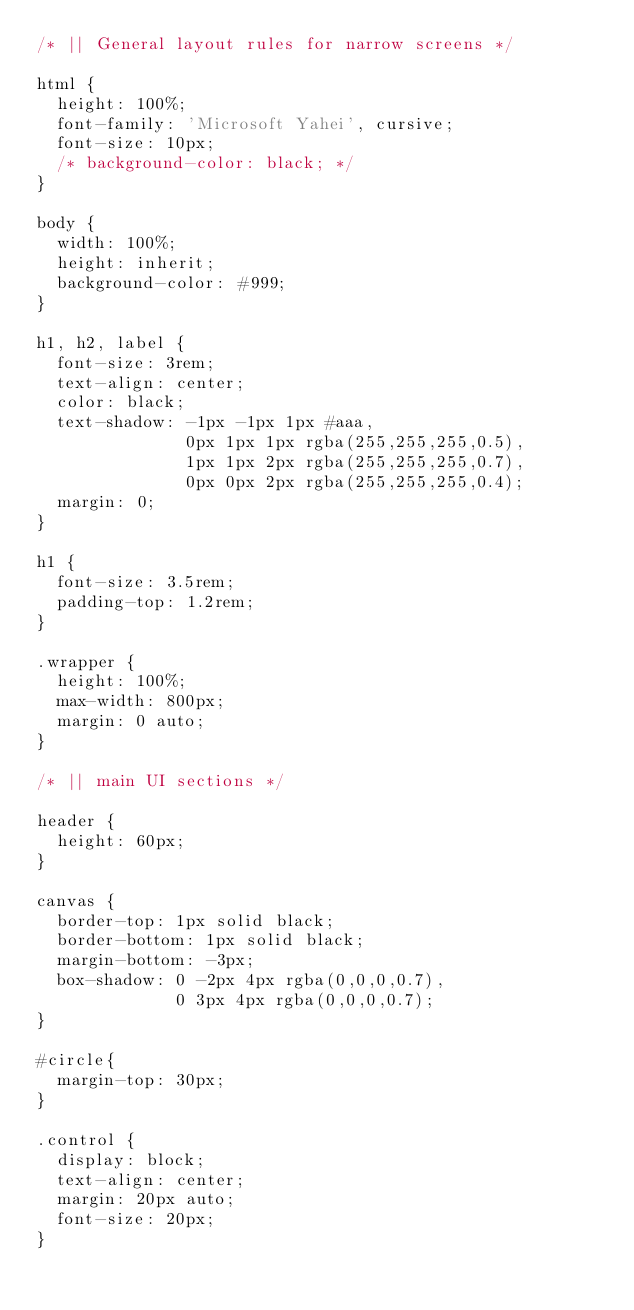Convert code to text. <code><loc_0><loc_0><loc_500><loc_500><_CSS_>/* || General layout rules for narrow screens */

html {
	height: 100%;
	font-family: 'Microsoft Yahei', cursive;
	font-size: 10px;
	/* background-color: black; */
}

body {
	width: 100%;
	height: inherit;
	background-color: #999;
}

h1, h2, label {
  font-size: 3rem;
  text-align: center;
  color: black;
  text-shadow: -1px -1px 1px #aaa,
               0px 1px 1px rgba(255,255,255,0.5),
               1px 1px 2px rgba(255,255,255,0.7),
               0px 0px 2px rgba(255,255,255,0.4);
  margin: 0;
}

h1 {
  font-size: 3.5rem;
  padding-top: 1.2rem;
}

.wrapper {
	height: 100%;
	max-width: 800px;
	margin: 0 auto;
}

/* || main UI sections */

header {
  height: 60px;
}

canvas {
  border-top: 1px solid black;
  border-bottom: 1px solid black;
  margin-bottom: -3px;
  box-shadow: 0 -2px 4px rgba(0,0,0,0.7),
              0 3px 4px rgba(0,0,0,0.7);
}

#circle{
  margin-top: 30px;
}

.control {
  display: block;
  text-align: center;
  margin: 20px auto;
  font-size: 20px;
}</code> 